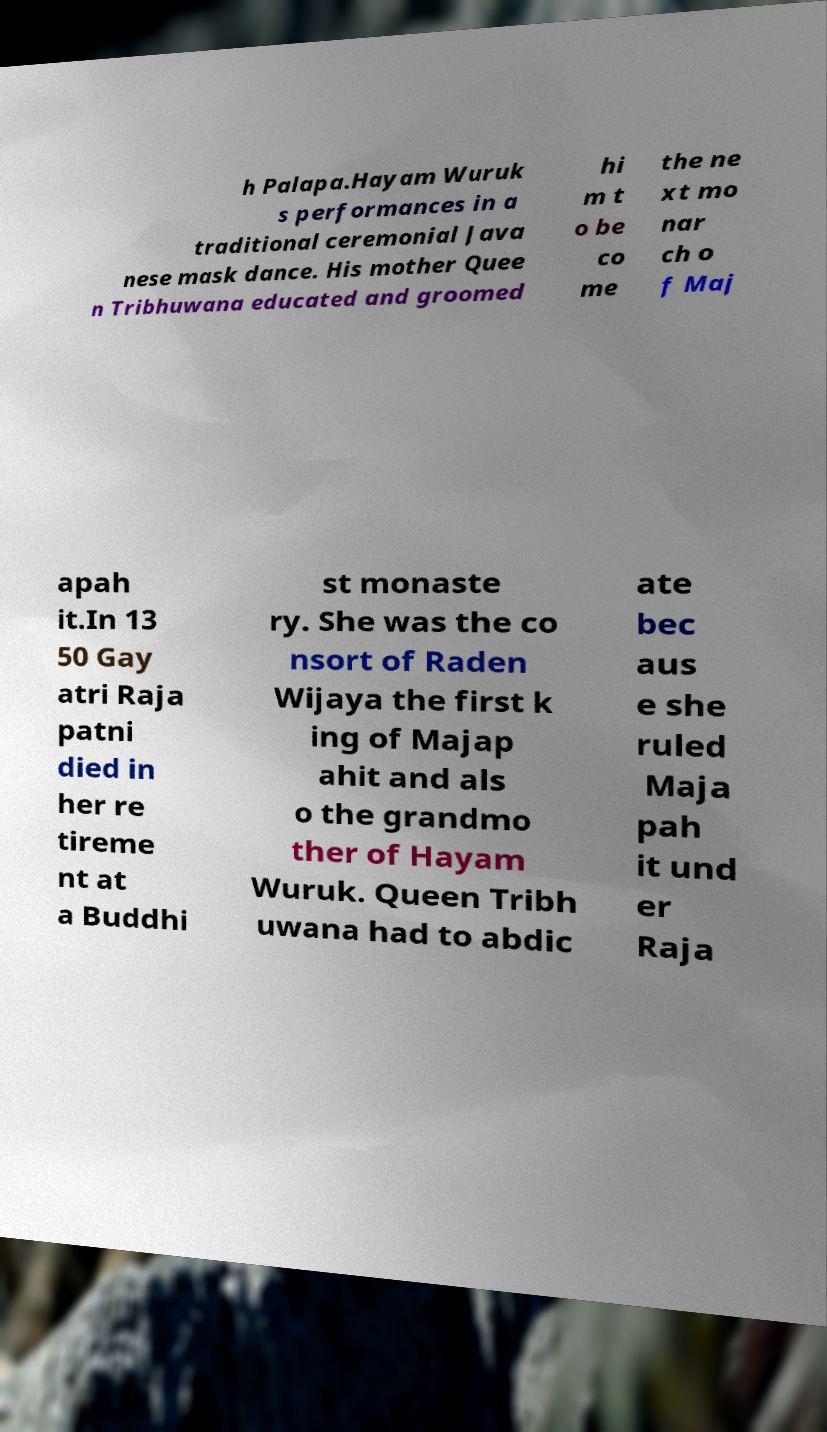What messages or text are displayed in this image? I need them in a readable, typed format. h Palapa.Hayam Wuruk s performances in a traditional ceremonial Java nese mask dance. His mother Quee n Tribhuwana educated and groomed hi m t o be co me the ne xt mo nar ch o f Maj apah it.In 13 50 Gay atri Raja patni died in her re tireme nt at a Buddhi st monaste ry. She was the co nsort of Raden Wijaya the first k ing of Majap ahit and als o the grandmo ther of Hayam Wuruk. Queen Tribh uwana had to abdic ate bec aus e she ruled Maja pah it und er Raja 